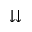<formula> <loc_0><loc_0><loc_500><loc_500>\downdownarrows</formula> 